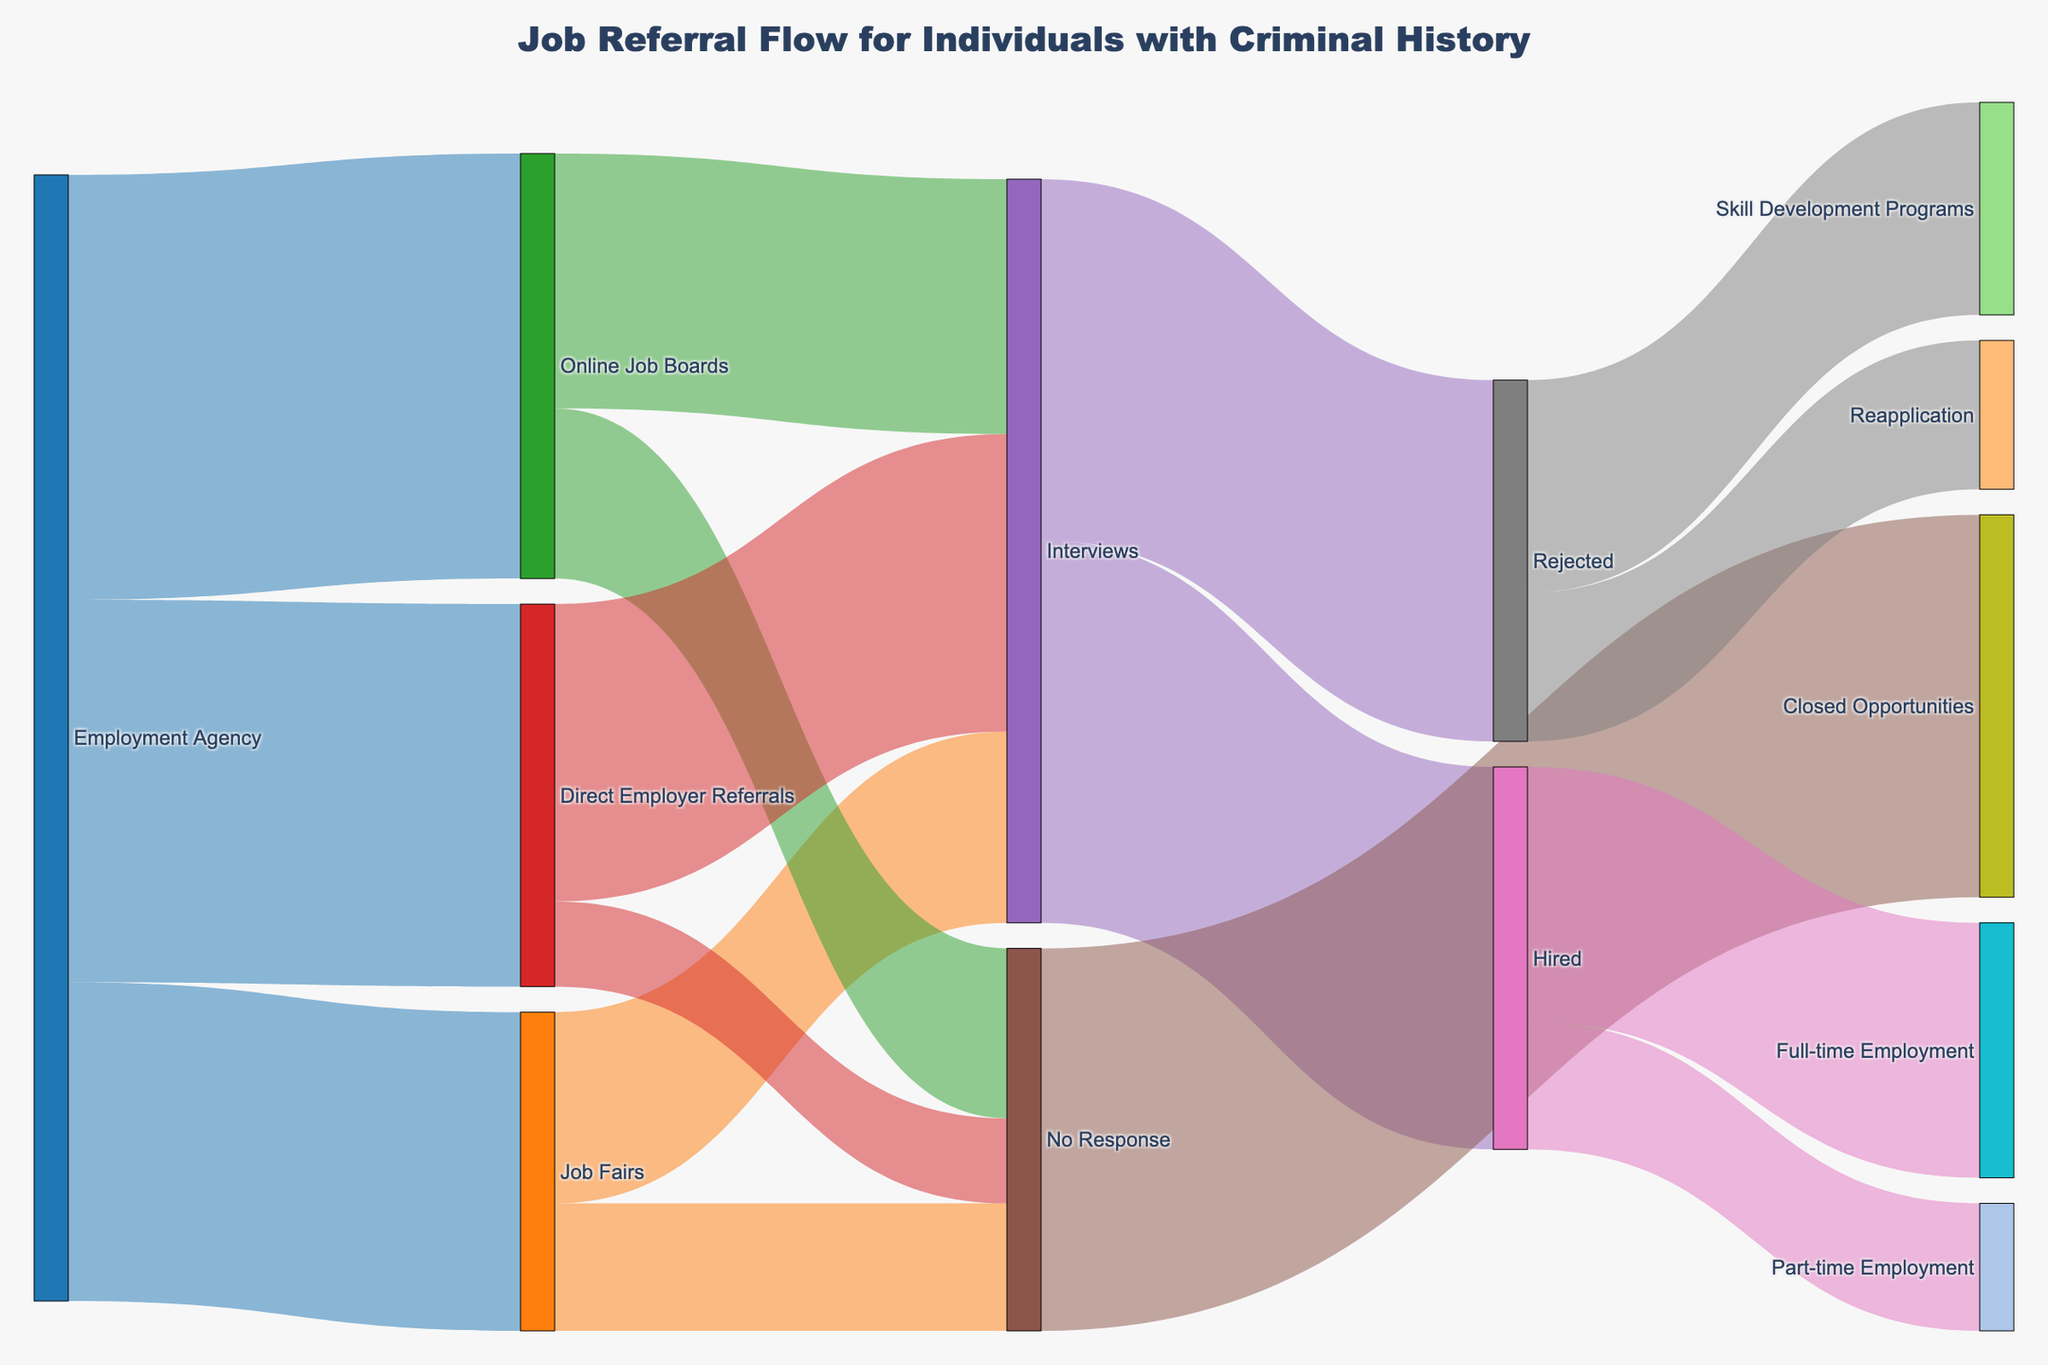what is the title of the figure? The title is usually located at the top of the figure and it can be easily found by reading the text at the top.
Answer: Job Referral Flow for Individuals with Criminal History What are the three main sources of job referrals? Look at the first set of nodes connected directly from "Employment Agency". The nodes representing "Job Fairs", "Online Job Boards", and "Direct Employer Referrals" are the main sources.
Answer: Job Fairs, Online Job Boards, Direct Employer Referrals What is the total number of people referred from job fairs to interviews? Find the connection between "Job Fairs" and "Interviews". The value on this link represents the number of people referred, which is 90.
Answer: 90 How many people from online job boards did not receive any response? Follow the link from "Online Job Boards" to "No Response". The value along this link indicates the number of people, which is 80.
Answer: 80 What is the total number of people who were hired? To find the total hires, add up the number of people in "Full-time Employment" and "Part-time Employment". The values are 120 and 60, respectively. Adding them gives 180.
Answer: 180 Which referral source has the highest number of interviews? Compare the number of interviews from each source. "Online Job Boards" has 120 interviews, "Direct Employer Referrals" has 140, and "Job Fairs" has 90. "Direct Employer Referrals" has the highest number of interviews at 140.
Answer: Direct Employer Referrals What is the ratio of hired individuals to those who were rejected? From the diagram, the number of hired individuals is 180 and the number of rejected individuals is 170. The ratio is 180 to 170, which simplifies to 18:17.
Answer: 18:17 Among the hired individuals, which type of employment is more common? Look at the connections from "Hired" to "Full-time Employment" (120) and "Part-time Employment" (60). Full-time employment is more common since 120 > 60.
Answer: Full-time Employment Compare the number of people who went to skill development programs to those who reapplied after rejection. From "Rejected", check the connections to "Skill Development Programs" (100) and "Reapplication" (70). 100 > 70, so more people went to skill development programs.
Answer: Skill Development Programs 